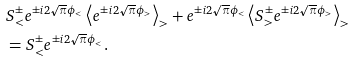<formula> <loc_0><loc_0><loc_500><loc_500>& S _ { < } ^ { \pm } e ^ { \pm i 2 \sqrt { \pi } \phi _ { < } } \left \langle e ^ { \pm i 2 \sqrt { \pi } \phi _ { > } } \right \rangle _ { > } + e ^ { \pm i 2 \sqrt { \pi } \phi _ { < } } \left \langle S _ { > } ^ { \pm } e ^ { \pm i 2 \sqrt { \pi } \phi _ { > } } \right \rangle _ { > } \\ & = S _ { < } ^ { \pm } e ^ { \pm i 2 \sqrt { \pi } \phi _ { < } } .</formula> 